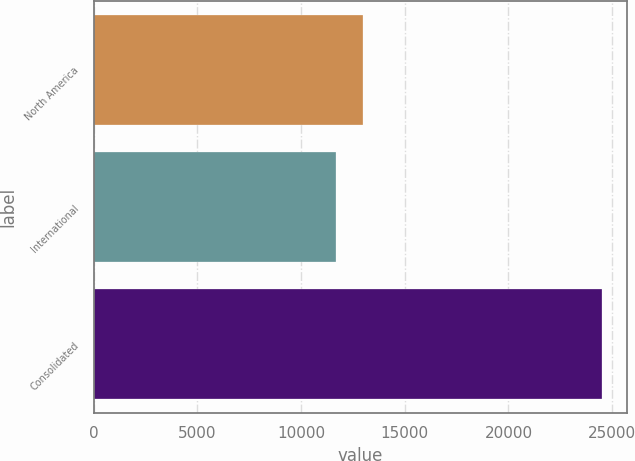<chart> <loc_0><loc_0><loc_500><loc_500><bar_chart><fcel>North America<fcel>International<fcel>Consolidated<nl><fcel>12963.8<fcel>11681<fcel>24509<nl></chart> 